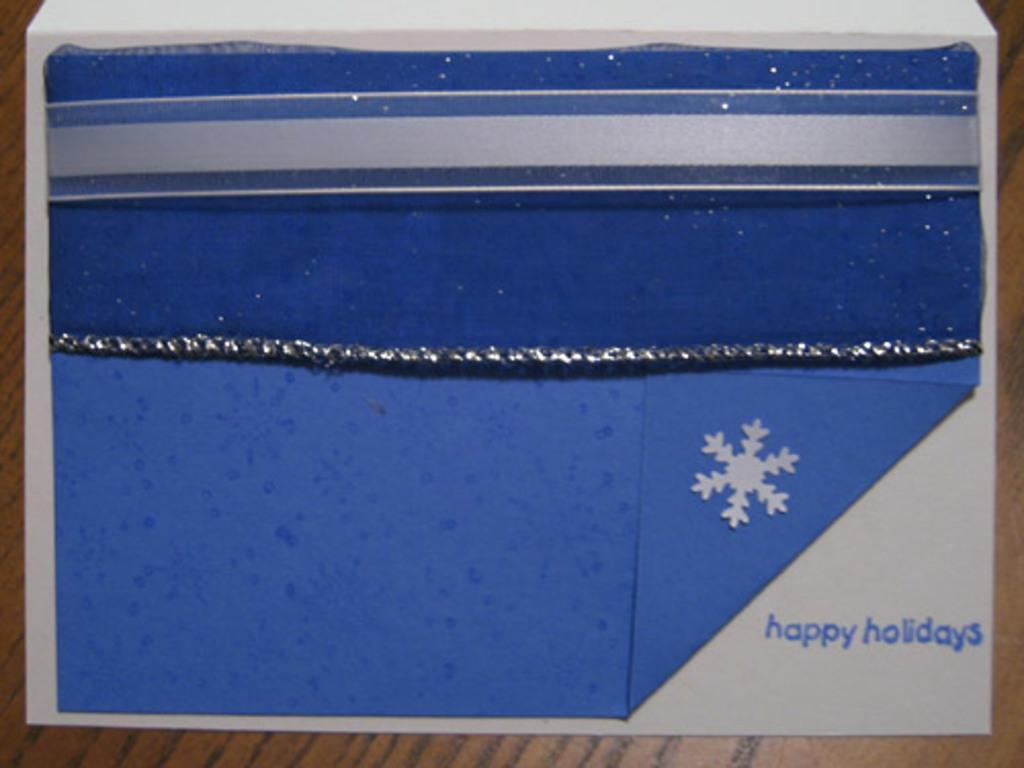<image>
Share a concise interpretation of the image provided. Something blue that has "happy holidays" written on it. 